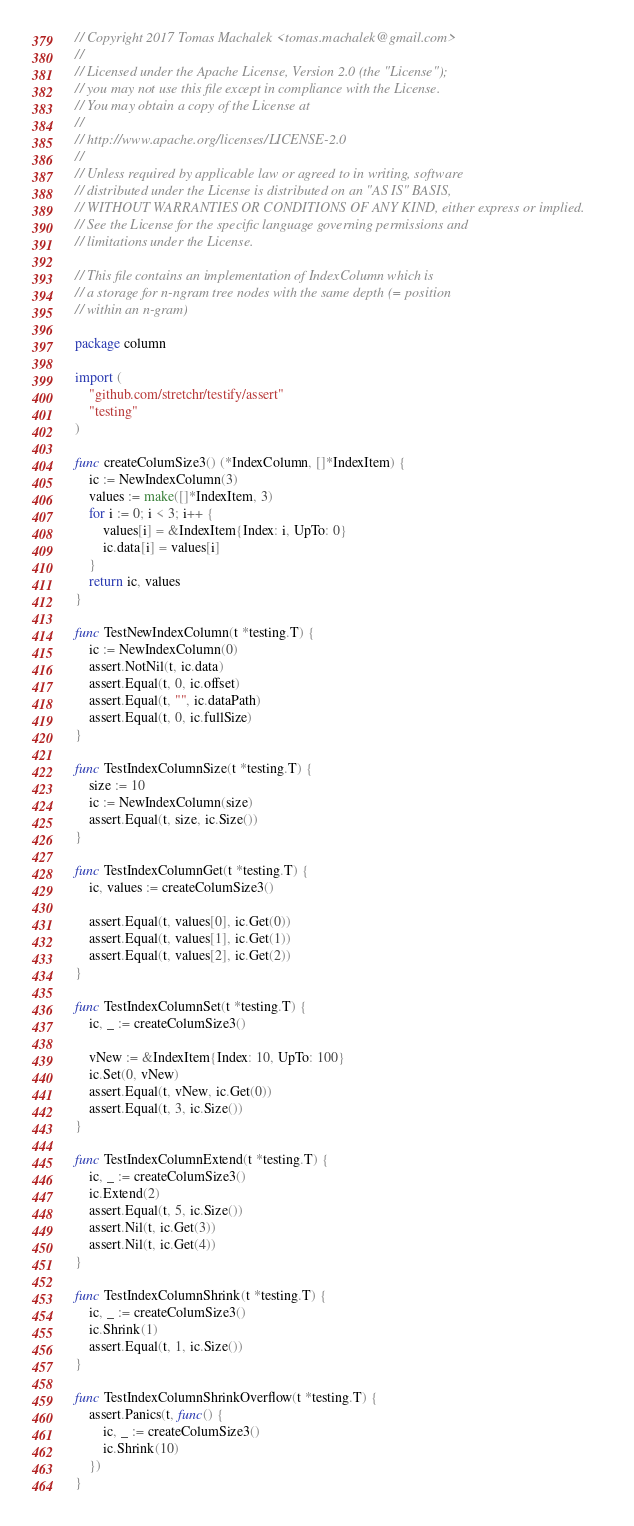<code> <loc_0><loc_0><loc_500><loc_500><_Go_>// Copyright 2017 Tomas Machalek <tomas.machalek@gmail.com>
//
// Licensed under the Apache License, Version 2.0 (the "License");
// you may not use this file except in compliance with the License.
// You may obtain a copy of the License at
//
// http://www.apache.org/licenses/LICENSE-2.0
//
// Unless required by applicable law or agreed to in writing, software
// distributed under the License is distributed on an "AS IS" BASIS,
// WITHOUT WARRANTIES OR CONDITIONS OF ANY KIND, either express or implied.
// See the License for the specific language governing permissions and
// limitations under the License.

// This file contains an implementation of IndexColumn which is
// a storage for n-ngram tree nodes with the same depth (= position
// within an n-gram)

package column

import (
	"github.com/stretchr/testify/assert"
	"testing"
)

func createColumSize3() (*IndexColumn, []*IndexItem) {
	ic := NewIndexColumn(3)
	values := make([]*IndexItem, 3)
	for i := 0; i < 3; i++ {
		values[i] = &IndexItem{Index: i, UpTo: 0}
		ic.data[i] = values[i]
	}
	return ic, values
}

func TestNewIndexColumn(t *testing.T) {
	ic := NewIndexColumn(0)
	assert.NotNil(t, ic.data)
	assert.Equal(t, 0, ic.offset)
	assert.Equal(t, "", ic.dataPath)
	assert.Equal(t, 0, ic.fullSize)
}

func TestIndexColumnSize(t *testing.T) {
	size := 10
	ic := NewIndexColumn(size)
	assert.Equal(t, size, ic.Size())
}

func TestIndexColumnGet(t *testing.T) {
	ic, values := createColumSize3()

	assert.Equal(t, values[0], ic.Get(0))
	assert.Equal(t, values[1], ic.Get(1))
	assert.Equal(t, values[2], ic.Get(2))
}

func TestIndexColumnSet(t *testing.T) {
	ic, _ := createColumSize3()

	vNew := &IndexItem{Index: 10, UpTo: 100}
	ic.Set(0, vNew)
	assert.Equal(t, vNew, ic.Get(0))
	assert.Equal(t, 3, ic.Size())
}

func TestIndexColumnExtend(t *testing.T) {
	ic, _ := createColumSize3()
	ic.Extend(2)
	assert.Equal(t, 5, ic.Size())
	assert.Nil(t, ic.Get(3))
	assert.Nil(t, ic.Get(4))
}

func TestIndexColumnShrink(t *testing.T) {
	ic, _ := createColumSize3()
	ic.Shrink(1)
	assert.Equal(t, 1, ic.Size())
}

func TestIndexColumnShrinkOverflow(t *testing.T) {
	assert.Panics(t, func() {
		ic, _ := createColumSize3()
		ic.Shrink(10)
	})
}
</code> 